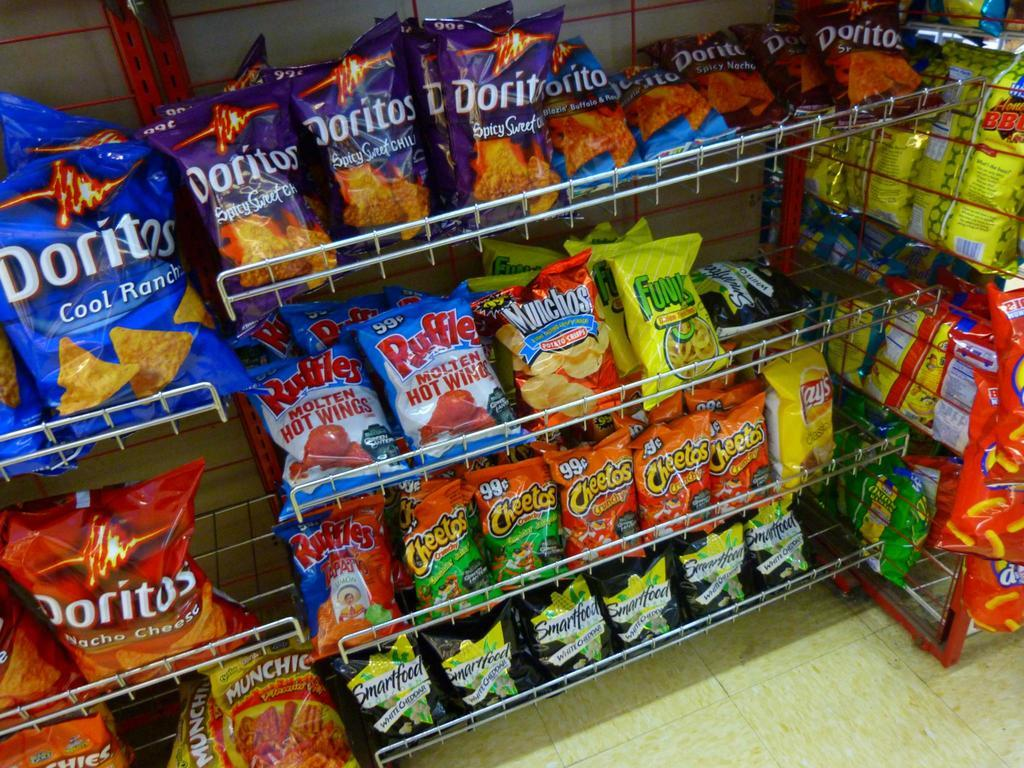<image>
Describe the image concisely. Several rows of chips on shelves, including Doritos 